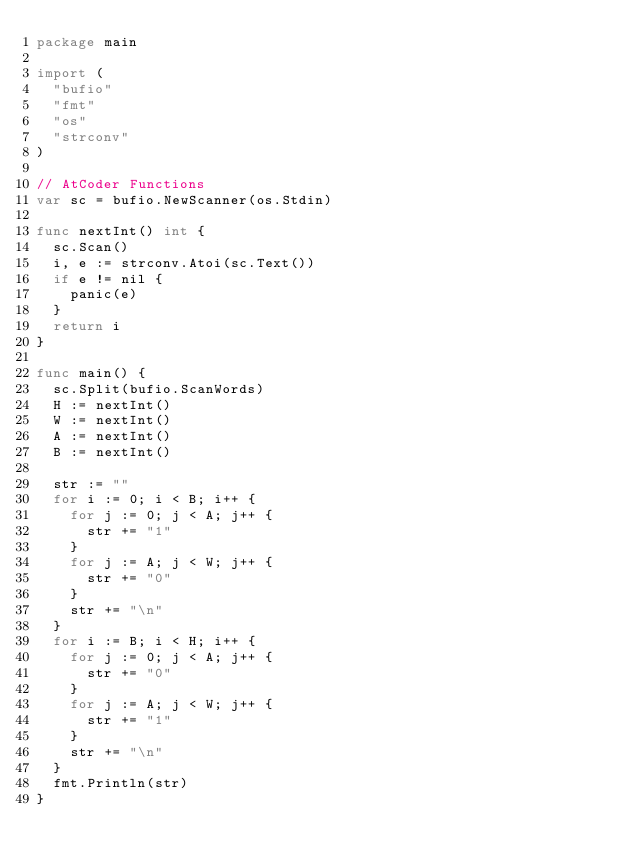Convert code to text. <code><loc_0><loc_0><loc_500><loc_500><_Go_>package main

import (
	"bufio"
	"fmt"
	"os"
	"strconv"
)

// AtCoder Functions
var sc = bufio.NewScanner(os.Stdin)

func nextInt() int {
	sc.Scan()
	i, e := strconv.Atoi(sc.Text())
	if e != nil {
		panic(e)
	}
	return i
}

func main() {
	sc.Split(bufio.ScanWords)
	H := nextInt()
	W := nextInt()
	A := nextInt()
	B := nextInt()

	str := ""
	for i := 0; i < B; i++ {
		for j := 0; j < A; j++ {
			str += "1"
		}
		for j := A; j < W; j++ {
			str += "0"
		}
		str += "\n"
	}
	for i := B; i < H; i++ {
		for j := 0; j < A; j++ {
			str += "0"
		}
		for j := A; j < W; j++ {
			str += "1"
		}
		str += "\n"
	}
	fmt.Println(str)
}
</code> 